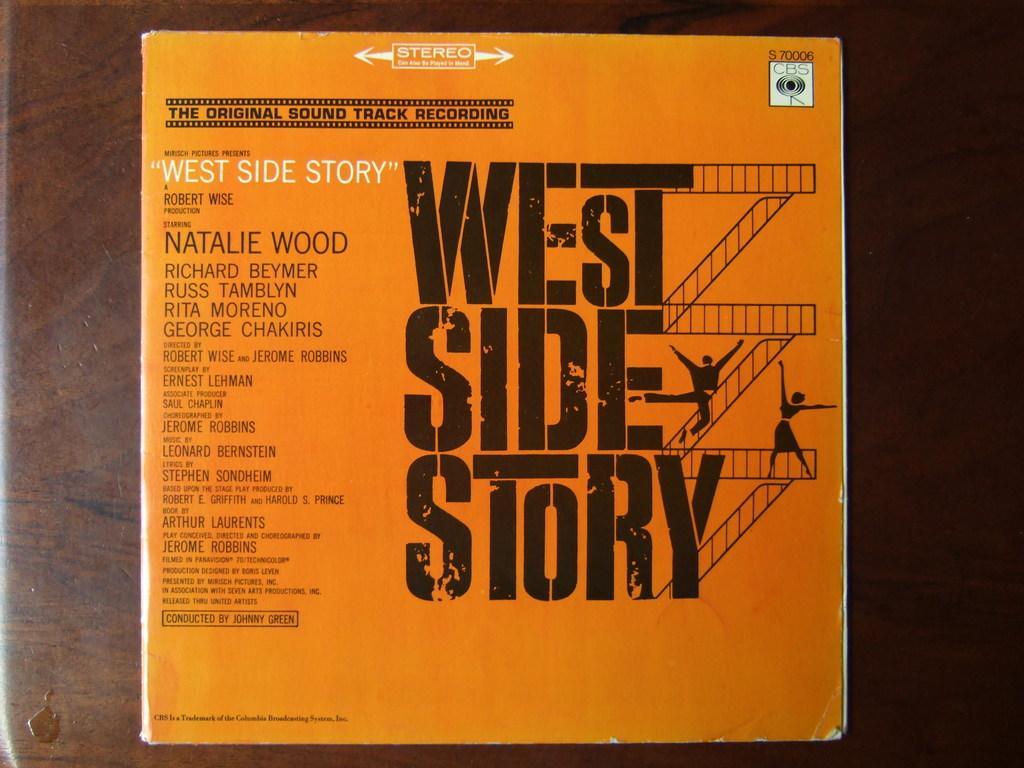Can you describe this image briefly? In this image I can see a board which is in orange color attached to some surface. 